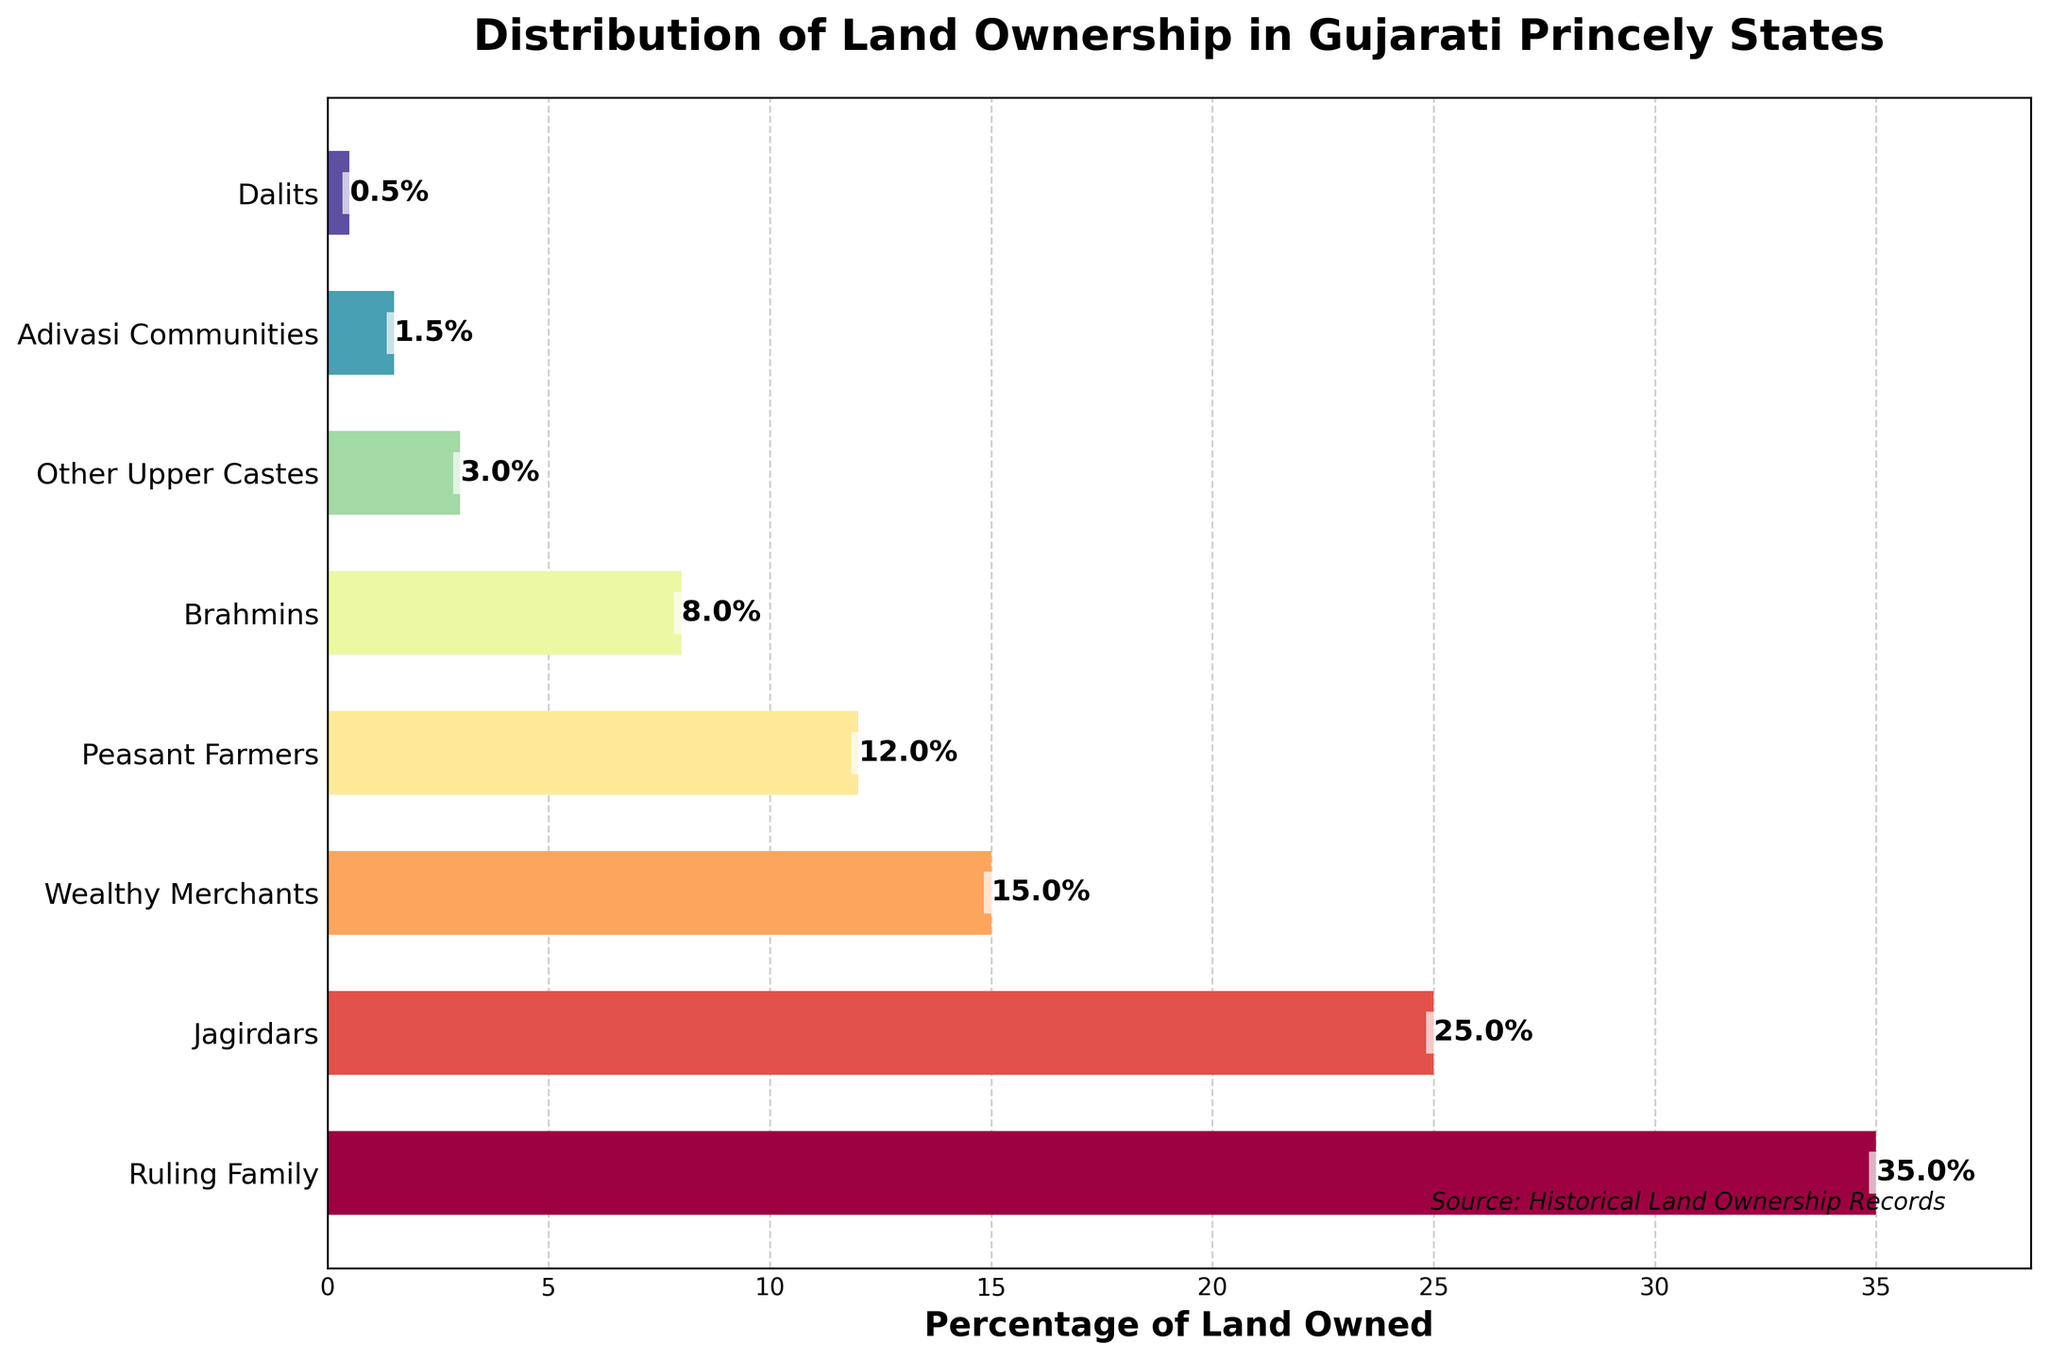Which social class owns the highest percentage of land? The bar for the "Ruling Family" is the longest, indicating the highest percentage of land ownership.
Answer: Ruling Family How much land do the Jagirdars and Wealthy Merchants own together? Jagirdars own 25% and Wealthy Merchants own 15%. Adding these gives 25% + 15% = 40%.
Answer: 40% Who owns more land, Peasant Farmers or Brahmins? Comparing the bars for Peasant Farmers (12%) and Brahmins (8%), it's clear that Peasant Farmers own more land.
Answer: Peasant Farmers What is the percentage difference in land ownership between Other Upper Castes and Adivasi Communities? Other Upper Castes own 3% and Adivasi Communities own 1.5%. The difference is 3% - 1.5% = 1.5%.
Answer: 1.5% How does the combined land ownership of Dalits and Adivasi Communities compare to that of Brahmins? Dalits own 0.5% and Adivasi Communities own 1.5%. Combined, this is 0.5% + 1.5% = 2%. Brahmins own 8%. Therefore, Brahmins own more land.
Answer: Brahmins own more What is the total percentage of land owned by groups other than the Ruling Family and Jagirdars? Excluding Ruling Family (35%) and Jagirdars (25%), the remaining groups own 15% + 12% + 8% + 3% + 1.5% + 0.5% = 40%.
Answer: 40% Which group has the second-highest land ownership? The second-longest bar corresponds to the Jagirdars with 25%.
Answer: Jagirdars How much more land does the Ruling Family own compared to Peasant Farmers? Ruling Family owns 35% and Peasant Farmers own 12%. The difference is 35% - 12% = 23%.
Answer: 23% Which social classes own a lower percentage of land than Peasant Farmers? Peasant Farmers own 12%. The social classes with lower percentages are Brahmins (8%), Other Upper Castes (3%), Adivasi Communities (1.5%), and Dalits (0.5%).
Answer: Brahmins, Other Upper Castes, Adivasi Communities, Dalits What is the average land ownership of Brahmins, Other Upper Castes, Adivasi Communities, and Dalits? Sum the percentages: 8% + 3% + 1.5% + 0.5% = 13%. The average is 13% / 4 = 3.25%.
Answer: 3.25% 